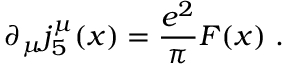<formula> <loc_0><loc_0><loc_500><loc_500>\partial _ { \mu } j _ { 5 } ^ { \mu } ( x ) = \frac { e ^ { 2 } } { \pi } F ( x ) \ .</formula> 